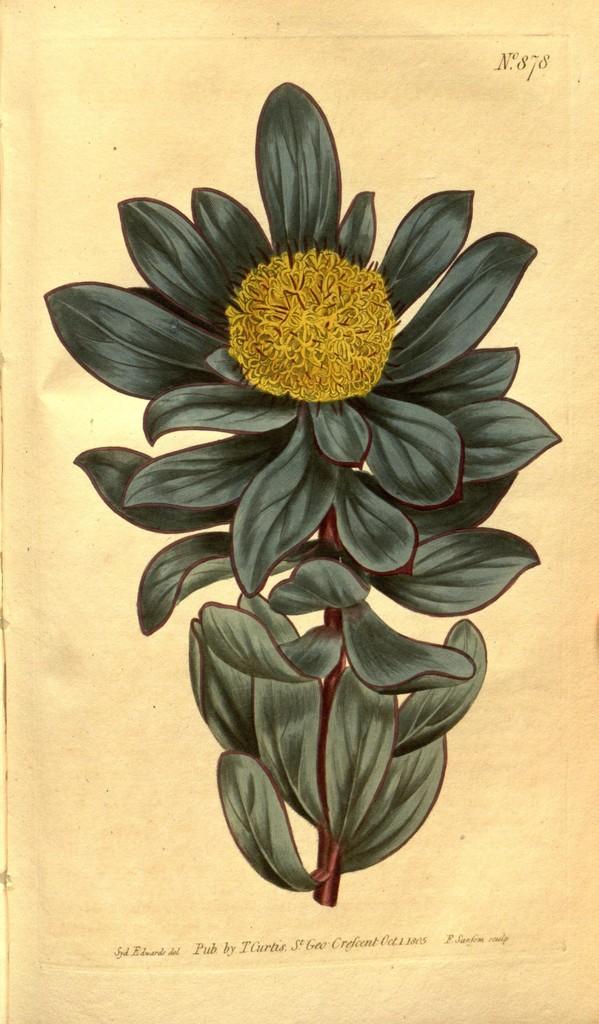Describe this image in one or two sentences. This image consists of a painting of s stem. To this stem I can see the leaves in green color and a flower which is in yellow color. At the bottom of this I can see some text. 